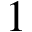<formula> <loc_0><loc_0><loc_500><loc_500>1</formula> 